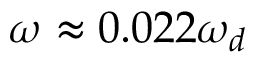Convert formula to latex. <formula><loc_0><loc_0><loc_500><loc_500>\omega \approx 0 . 0 2 2 \omega _ { d }</formula> 